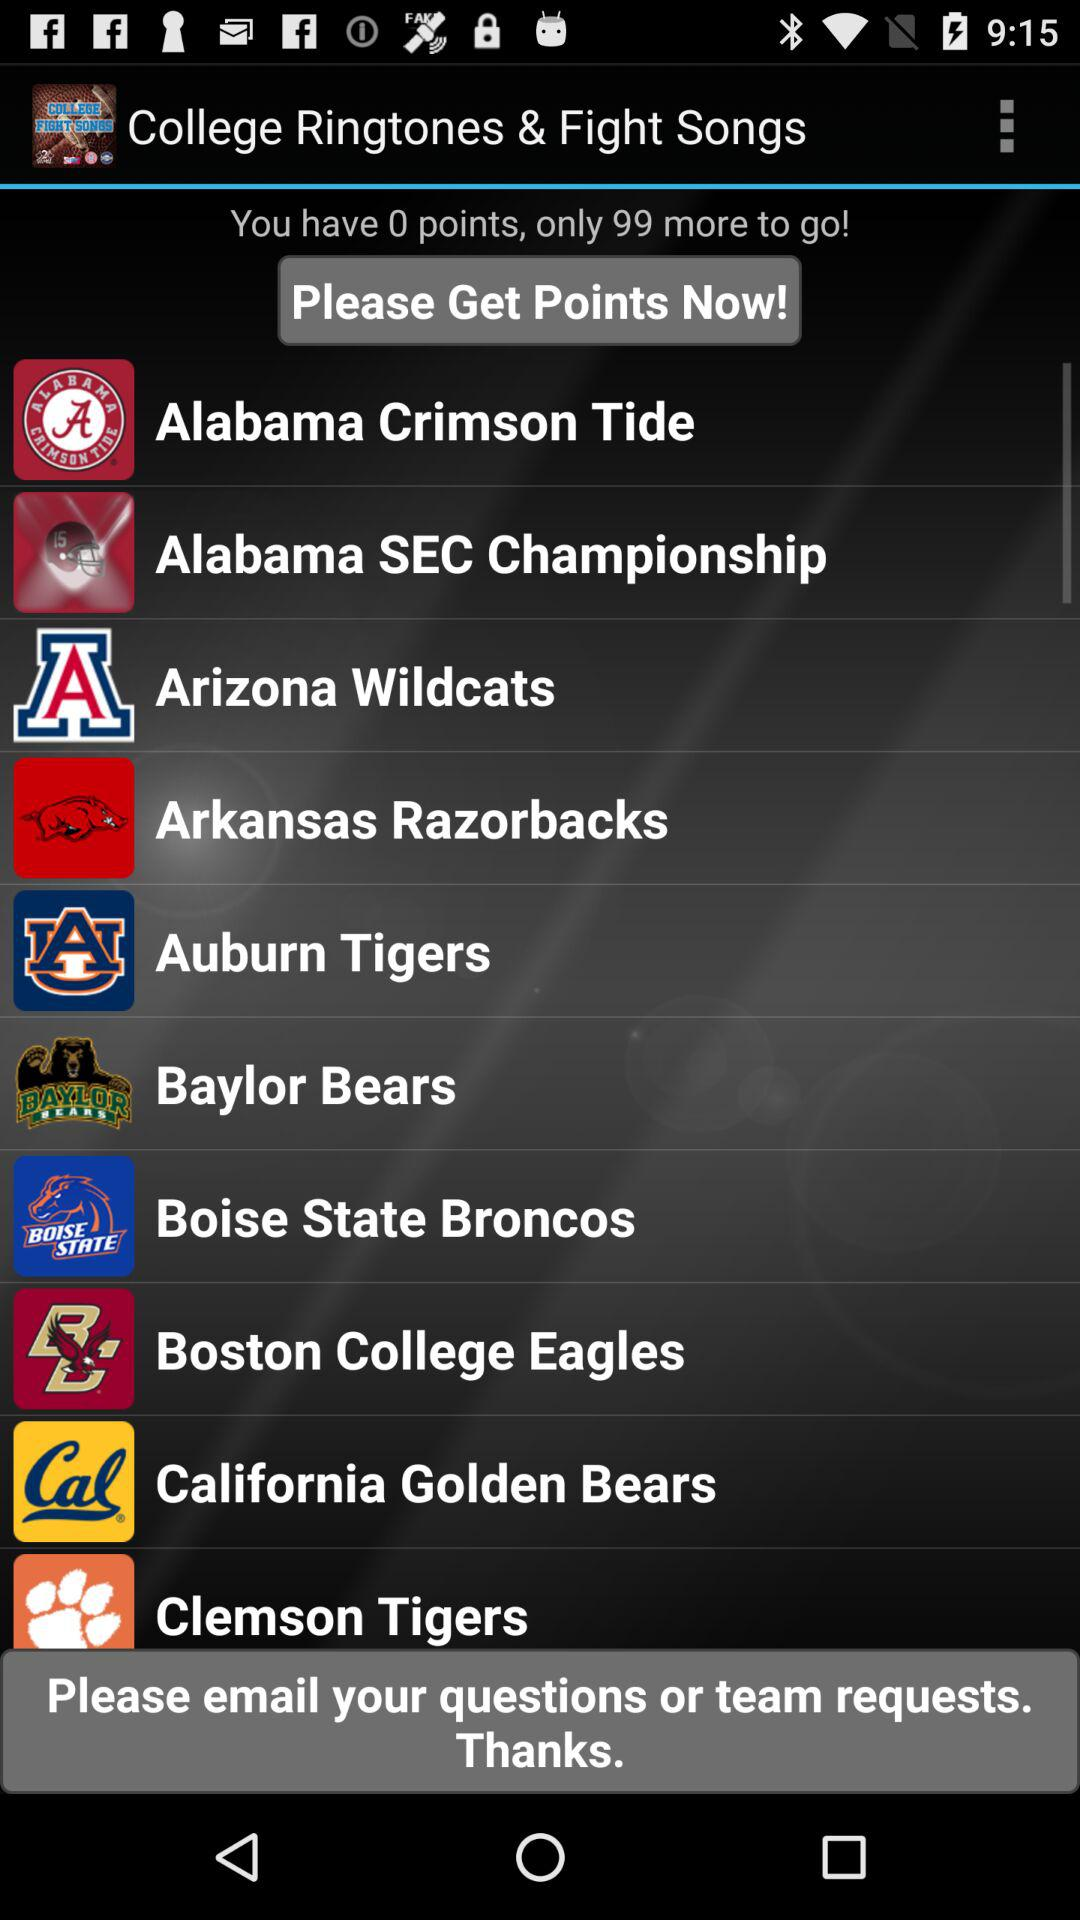How many more points do I need to unlock the next team?
Answer the question using a single word or phrase. 99 